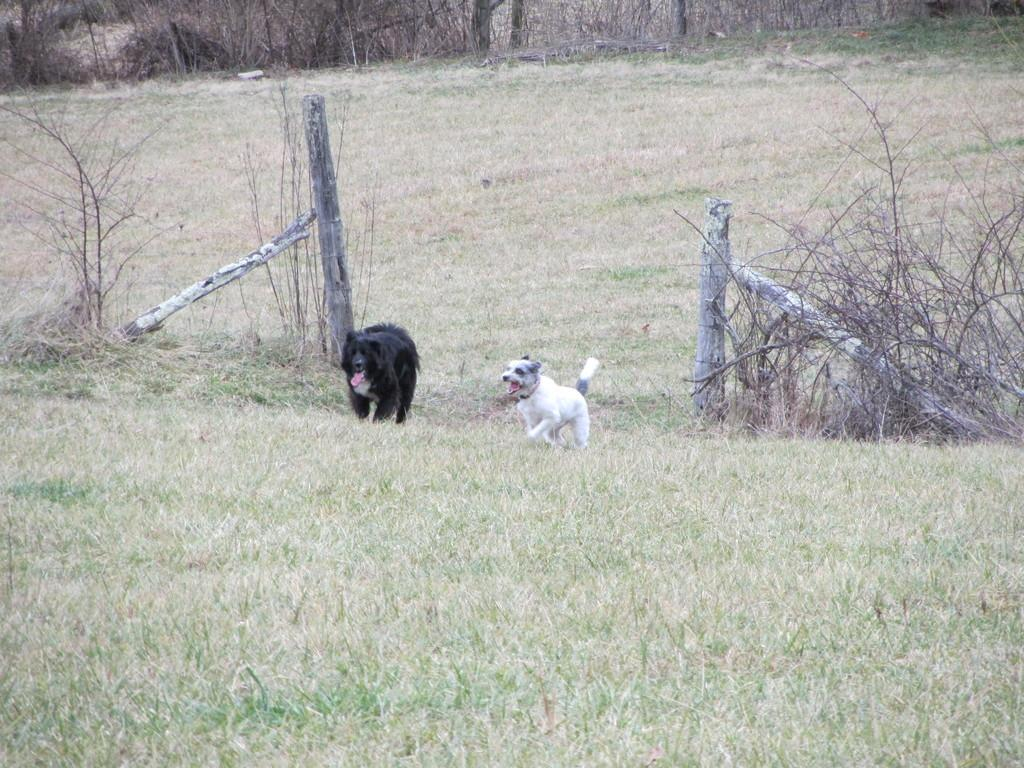What animals are in the middle of the image? There are dogs in the middle of the image. What type of ground is visible at the bottom of the image? There is grass at the bottom of the image. What objects can be seen on either side of the image? There are dried sticks on either side of the image. Can you see any icicles hanging from the dried sticks in the image? There are no icicles present in the image; it features dogs, grass, and dried sticks. What type of plants are growing in the alley in the image? There is no alley present in the image, and therefore no plants growing in it. 